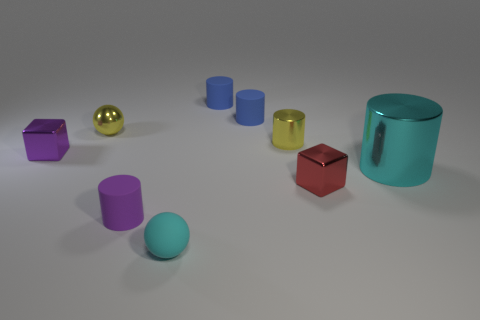Are there any objects with a reflective surface? Yes, all the objects in the image appear to have reflective surfaces, varying in the degree of reflectivity.  Which object is the largest? The largest object in the image is the teal cylindrical container on the right. 